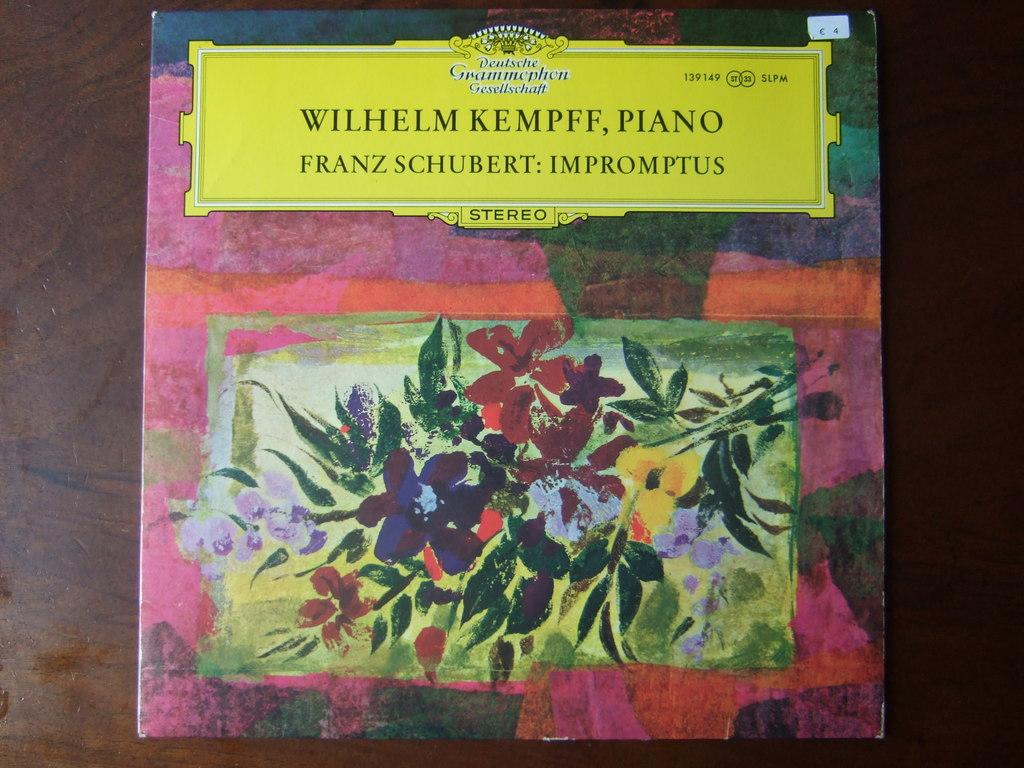<image>
Share a concise interpretation of the image provided. an album of Franz Schubert: Imptromptus sitting on a table 